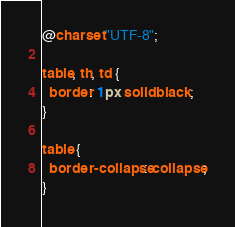<code> <loc_0><loc_0><loc_500><loc_500><_CSS_>@charset "UTF-8";

table, th, td {
  border: 1px solid black;
}

table {
  border-collapse: collapse;
}
</code> 